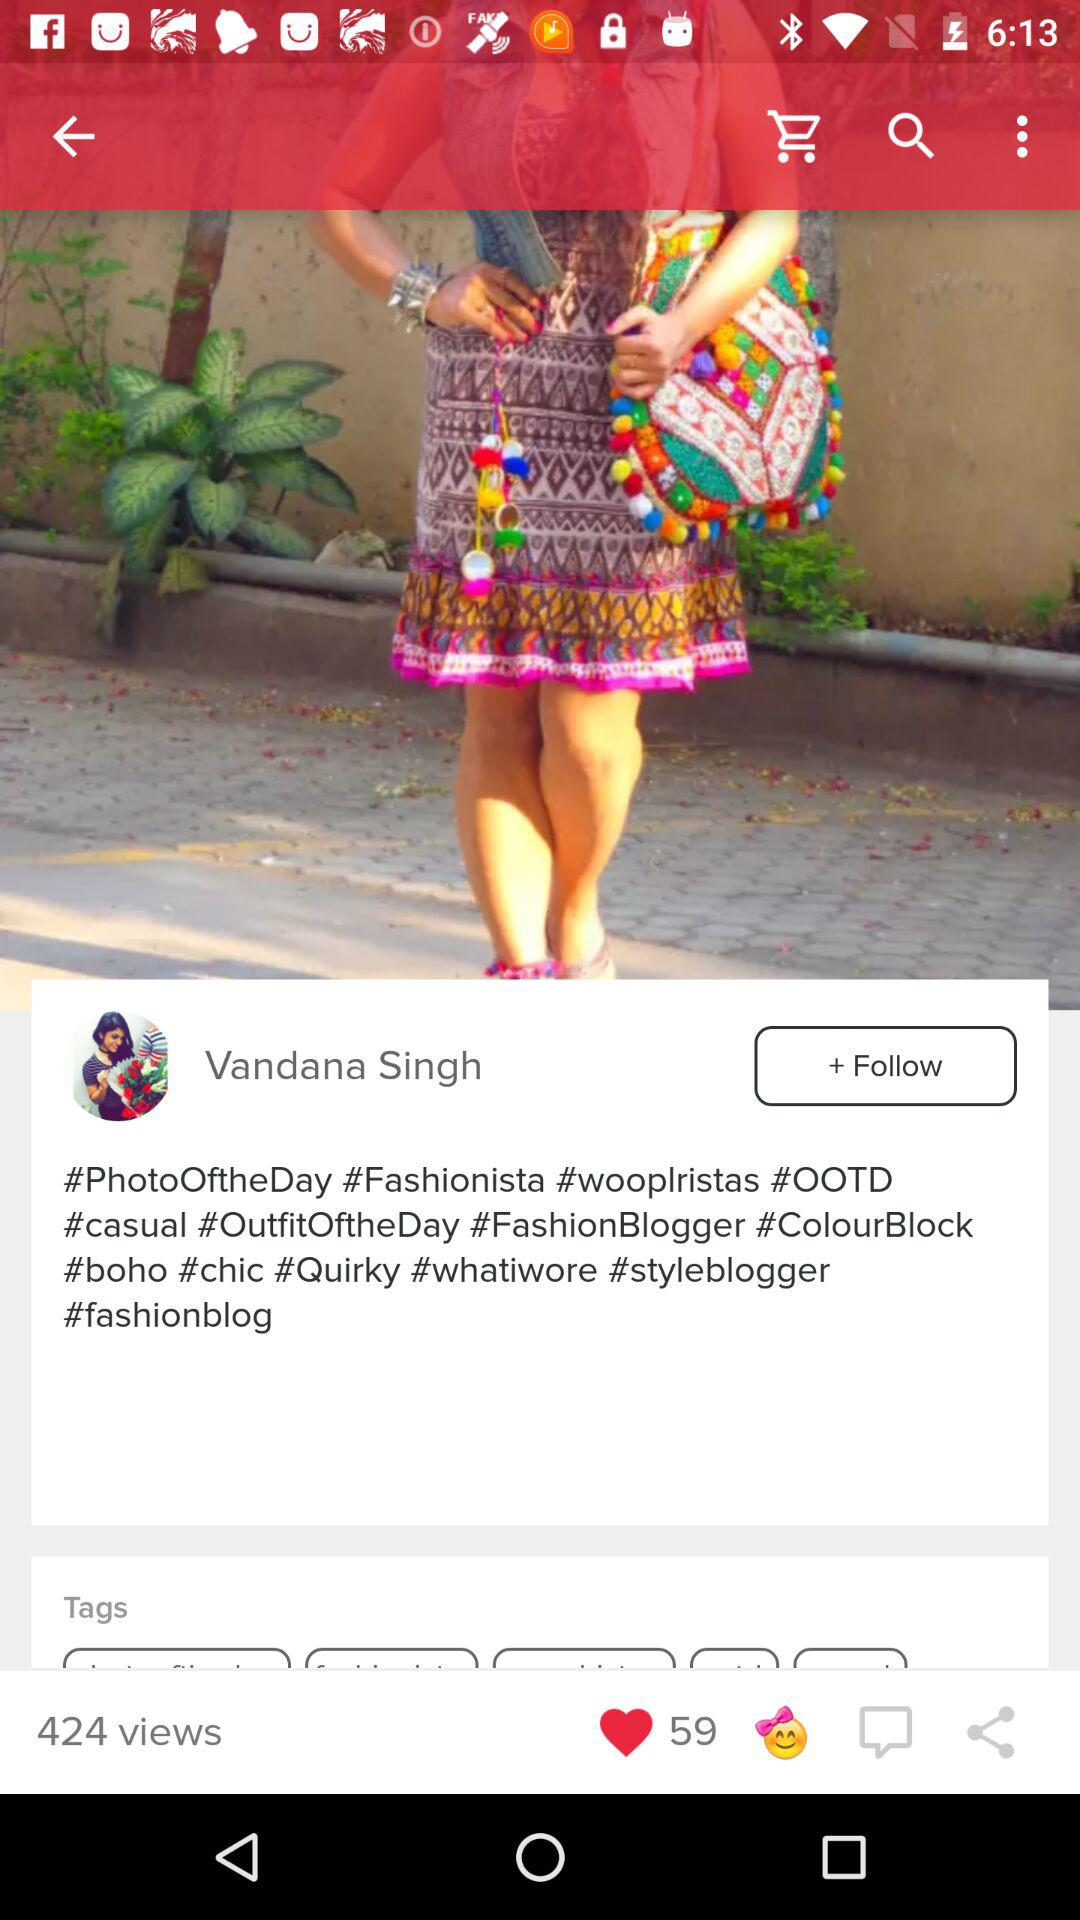What is the name? The name is Vandana Singh. 